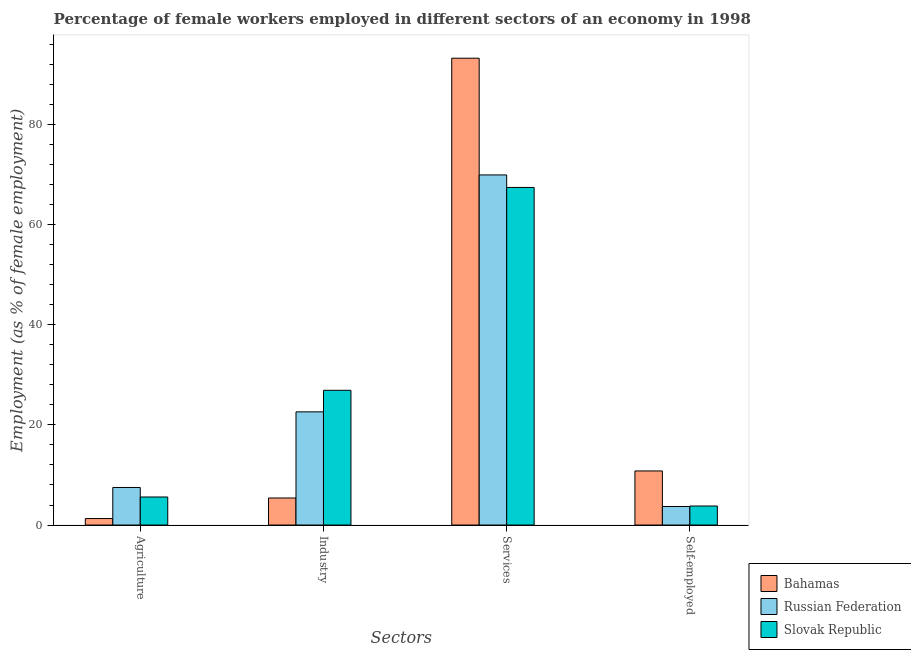How many groups of bars are there?
Your response must be concise. 4. Are the number of bars per tick equal to the number of legend labels?
Provide a short and direct response. Yes. How many bars are there on the 2nd tick from the left?
Offer a terse response. 3. What is the label of the 3rd group of bars from the left?
Give a very brief answer. Services. What is the percentage of self employed female workers in Bahamas?
Your answer should be very brief. 10.8. Across all countries, what is the maximum percentage of female workers in industry?
Offer a terse response. 26.9. Across all countries, what is the minimum percentage of female workers in industry?
Give a very brief answer. 5.4. In which country was the percentage of female workers in services maximum?
Ensure brevity in your answer.  Bahamas. In which country was the percentage of self employed female workers minimum?
Your response must be concise. Russian Federation. What is the total percentage of female workers in services in the graph?
Offer a very short reply. 230.5. What is the difference between the percentage of female workers in industry in Russian Federation and that in Bahamas?
Your answer should be very brief. 17.2. What is the difference between the percentage of female workers in industry in Bahamas and the percentage of female workers in agriculture in Slovak Republic?
Keep it short and to the point. -0.2. What is the average percentage of self employed female workers per country?
Offer a very short reply. 6.1. What is the difference between the percentage of female workers in agriculture and percentage of female workers in services in Slovak Republic?
Keep it short and to the point. -61.8. In how many countries, is the percentage of female workers in services greater than 40 %?
Your response must be concise. 3. What is the ratio of the percentage of female workers in industry in Slovak Republic to that in Russian Federation?
Give a very brief answer. 1.19. What is the difference between the highest and the second highest percentage of female workers in agriculture?
Provide a succinct answer. 1.9. What is the difference between the highest and the lowest percentage of female workers in services?
Offer a very short reply. 25.8. In how many countries, is the percentage of self employed female workers greater than the average percentage of self employed female workers taken over all countries?
Your answer should be compact. 1. Is the sum of the percentage of female workers in services in Bahamas and Russian Federation greater than the maximum percentage of female workers in industry across all countries?
Keep it short and to the point. Yes. Is it the case that in every country, the sum of the percentage of self employed female workers and percentage of female workers in services is greater than the sum of percentage of female workers in agriculture and percentage of female workers in industry?
Ensure brevity in your answer.  Yes. What does the 1st bar from the left in Agriculture represents?
Your answer should be very brief. Bahamas. What does the 3rd bar from the right in Services represents?
Provide a succinct answer. Bahamas. Is it the case that in every country, the sum of the percentage of female workers in agriculture and percentage of female workers in industry is greater than the percentage of female workers in services?
Your answer should be very brief. No. How many bars are there?
Offer a terse response. 12. How many countries are there in the graph?
Offer a terse response. 3. Does the graph contain any zero values?
Give a very brief answer. No. Does the graph contain grids?
Offer a very short reply. No. Where does the legend appear in the graph?
Your answer should be compact. Bottom right. How many legend labels are there?
Ensure brevity in your answer.  3. What is the title of the graph?
Your answer should be compact. Percentage of female workers employed in different sectors of an economy in 1998. What is the label or title of the X-axis?
Your answer should be compact. Sectors. What is the label or title of the Y-axis?
Ensure brevity in your answer.  Employment (as % of female employment). What is the Employment (as % of female employment) of Bahamas in Agriculture?
Provide a short and direct response. 1.3. What is the Employment (as % of female employment) in Russian Federation in Agriculture?
Provide a succinct answer. 7.5. What is the Employment (as % of female employment) of Slovak Republic in Agriculture?
Your answer should be compact. 5.6. What is the Employment (as % of female employment) of Bahamas in Industry?
Keep it short and to the point. 5.4. What is the Employment (as % of female employment) in Russian Federation in Industry?
Keep it short and to the point. 22.6. What is the Employment (as % of female employment) of Slovak Republic in Industry?
Your answer should be compact. 26.9. What is the Employment (as % of female employment) in Bahamas in Services?
Make the answer very short. 93.2. What is the Employment (as % of female employment) in Russian Federation in Services?
Your answer should be very brief. 69.9. What is the Employment (as % of female employment) of Slovak Republic in Services?
Make the answer very short. 67.4. What is the Employment (as % of female employment) in Bahamas in Self-employed?
Your response must be concise. 10.8. What is the Employment (as % of female employment) of Russian Federation in Self-employed?
Keep it short and to the point. 3.7. What is the Employment (as % of female employment) of Slovak Republic in Self-employed?
Provide a short and direct response. 3.8. Across all Sectors, what is the maximum Employment (as % of female employment) of Bahamas?
Keep it short and to the point. 93.2. Across all Sectors, what is the maximum Employment (as % of female employment) in Russian Federation?
Offer a very short reply. 69.9. Across all Sectors, what is the maximum Employment (as % of female employment) of Slovak Republic?
Provide a short and direct response. 67.4. Across all Sectors, what is the minimum Employment (as % of female employment) of Bahamas?
Your answer should be very brief. 1.3. Across all Sectors, what is the minimum Employment (as % of female employment) in Russian Federation?
Provide a succinct answer. 3.7. Across all Sectors, what is the minimum Employment (as % of female employment) in Slovak Republic?
Your response must be concise. 3.8. What is the total Employment (as % of female employment) of Bahamas in the graph?
Make the answer very short. 110.7. What is the total Employment (as % of female employment) of Russian Federation in the graph?
Your answer should be very brief. 103.7. What is the total Employment (as % of female employment) of Slovak Republic in the graph?
Provide a succinct answer. 103.7. What is the difference between the Employment (as % of female employment) in Bahamas in Agriculture and that in Industry?
Your answer should be compact. -4.1. What is the difference between the Employment (as % of female employment) of Russian Federation in Agriculture and that in Industry?
Offer a very short reply. -15.1. What is the difference between the Employment (as % of female employment) of Slovak Republic in Agriculture and that in Industry?
Ensure brevity in your answer.  -21.3. What is the difference between the Employment (as % of female employment) of Bahamas in Agriculture and that in Services?
Your response must be concise. -91.9. What is the difference between the Employment (as % of female employment) of Russian Federation in Agriculture and that in Services?
Give a very brief answer. -62.4. What is the difference between the Employment (as % of female employment) of Slovak Republic in Agriculture and that in Services?
Your response must be concise. -61.8. What is the difference between the Employment (as % of female employment) in Russian Federation in Agriculture and that in Self-employed?
Your answer should be very brief. 3.8. What is the difference between the Employment (as % of female employment) in Bahamas in Industry and that in Services?
Ensure brevity in your answer.  -87.8. What is the difference between the Employment (as % of female employment) in Russian Federation in Industry and that in Services?
Your answer should be compact. -47.3. What is the difference between the Employment (as % of female employment) in Slovak Republic in Industry and that in Services?
Provide a short and direct response. -40.5. What is the difference between the Employment (as % of female employment) of Russian Federation in Industry and that in Self-employed?
Your response must be concise. 18.9. What is the difference between the Employment (as % of female employment) in Slovak Republic in Industry and that in Self-employed?
Provide a short and direct response. 23.1. What is the difference between the Employment (as % of female employment) in Bahamas in Services and that in Self-employed?
Give a very brief answer. 82.4. What is the difference between the Employment (as % of female employment) of Russian Federation in Services and that in Self-employed?
Your answer should be very brief. 66.2. What is the difference between the Employment (as % of female employment) in Slovak Republic in Services and that in Self-employed?
Ensure brevity in your answer.  63.6. What is the difference between the Employment (as % of female employment) of Bahamas in Agriculture and the Employment (as % of female employment) of Russian Federation in Industry?
Give a very brief answer. -21.3. What is the difference between the Employment (as % of female employment) of Bahamas in Agriculture and the Employment (as % of female employment) of Slovak Republic in Industry?
Your answer should be compact. -25.6. What is the difference between the Employment (as % of female employment) of Russian Federation in Agriculture and the Employment (as % of female employment) of Slovak Republic in Industry?
Your answer should be very brief. -19.4. What is the difference between the Employment (as % of female employment) in Bahamas in Agriculture and the Employment (as % of female employment) in Russian Federation in Services?
Give a very brief answer. -68.6. What is the difference between the Employment (as % of female employment) in Bahamas in Agriculture and the Employment (as % of female employment) in Slovak Republic in Services?
Offer a very short reply. -66.1. What is the difference between the Employment (as % of female employment) of Russian Federation in Agriculture and the Employment (as % of female employment) of Slovak Republic in Services?
Your answer should be compact. -59.9. What is the difference between the Employment (as % of female employment) in Bahamas in Agriculture and the Employment (as % of female employment) in Russian Federation in Self-employed?
Make the answer very short. -2.4. What is the difference between the Employment (as % of female employment) in Bahamas in Agriculture and the Employment (as % of female employment) in Slovak Republic in Self-employed?
Offer a very short reply. -2.5. What is the difference between the Employment (as % of female employment) of Bahamas in Industry and the Employment (as % of female employment) of Russian Federation in Services?
Your answer should be very brief. -64.5. What is the difference between the Employment (as % of female employment) of Bahamas in Industry and the Employment (as % of female employment) of Slovak Republic in Services?
Ensure brevity in your answer.  -62. What is the difference between the Employment (as % of female employment) of Russian Federation in Industry and the Employment (as % of female employment) of Slovak Republic in Services?
Give a very brief answer. -44.8. What is the difference between the Employment (as % of female employment) in Bahamas in Industry and the Employment (as % of female employment) in Russian Federation in Self-employed?
Your response must be concise. 1.7. What is the difference between the Employment (as % of female employment) in Russian Federation in Industry and the Employment (as % of female employment) in Slovak Republic in Self-employed?
Offer a terse response. 18.8. What is the difference between the Employment (as % of female employment) in Bahamas in Services and the Employment (as % of female employment) in Russian Federation in Self-employed?
Your answer should be compact. 89.5. What is the difference between the Employment (as % of female employment) in Bahamas in Services and the Employment (as % of female employment) in Slovak Republic in Self-employed?
Your answer should be very brief. 89.4. What is the difference between the Employment (as % of female employment) in Russian Federation in Services and the Employment (as % of female employment) in Slovak Republic in Self-employed?
Your answer should be very brief. 66.1. What is the average Employment (as % of female employment) in Bahamas per Sectors?
Keep it short and to the point. 27.68. What is the average Employment (as % of female employment) of Russian Federation per Sectors?
Your response must be concise. 25.93. What is the average Employment (as % of female employment) in Slovak Republic per Sectors?
Offer a terse response. 25.93. What is the difference between the Employment (as % of female employment) in Bahamas and Employment (as % of female employment) in Slovak Republic in Agriculture?
Offer a terse response. -4.3. What is the difference between the Employment (as % of female employment) of Russian Federation and Employment (as % of female employment) of Slovak Republic in Agriculture?
Give a very brief answer. 1.9. What is the difference between the Employment (as % of female employment) of Bahamas and Employment (as % of female employment) of Russian Federation in Industry?
Give a very brief answer. -17.2. What is the difference between the Employment (as % of female employment) of Bahamas and Employment (as % of female employment) of Slovak Republic in Industry?
Your answer should be compact. -21.5. What is the difference between the Employment (as % of female employment) of Russian Federation and Employment (as % of female employment) of Slovak Republic in Industry?
Ensure brevity in your answer.  -4.3. What is the difference between the Employment (as % of female employment) of Bahamas and Employment (as % of female employment) of Russian Federation in Services?
Make the answer very short. 23.3. What is the difference between the Employment (as % of female employment) in Bahamas and Employment (as % of female employment) in Slovak Republic in Services?
Ensure brevity in your answer.  25.8. What is the difference between the Employment (as % of female employment) of Russian Federation and Employment (as % of female employment) of Slovak Republic in Services?
Your response must be concise. 2.5. What is the difference between the Employment (as % of female employment) of Bahamas and Employment (as % of female employment) of Russian Federation in Self-employed?
Give a very brief answer. 7.1. What is the difference between the Employment (as % of female employment) in Bahamas and Employment (as % of female employment) in Slovak Republic in Self-employed?
Offer a very short reply. 7. What is the difference between the Employment (as % of female employment) in Russian Federation and Employment (as % of female employment) in Slovak Republic in Self-employed?
Make the answer very short. -0.1. What is the ratio of the Employment (as % of female employment) in Bahamas in Agriculture to that in Industry?
Your answer should be very brief. 0.24. What is the ratio of the Employment (as % of female employment) in Russian Federation in Agriculture to that in Industry?
Ensure brevity in your answer.  0.33. What is the ratio of the Employment (as % of female employment) of Slovak Republic in Agriculture to that in Industry?
Offer a very short reply. 0.21. What is the ratio of the Employment (as % of female employment) of Bahamas in Agriculture to that in Services?
Give a very brief answer. 0.01. What is the ratio of the Employment (as % of female employment) of Russian Federation in Agriculture to that in Services?
Your answer should be very brief. 0.11. What is the ratio of the Employment (as % of female employment) of Slovak Republic in Agriculture to that in Services?
Your answer should be very brief. 0.08. What is the ratio of the Employment (as % of female employment) in Bahamas in Agriculture to that in Self-employed?
Offer a very short reply. 0.12. What is the ratio of the Employment (as % of female employment) in Russian Federation in Agriculture to that in Self-employed?
Offer a very short reply. 2.03. What is the ratio of the Employment (as % of female employment) in Slovak Republic in Agriculture to that in Self-employed?
Ensure brevity in your answer.  1.47. What is the ratio of the Employment (as % of female employment) in Bahamas in Industry to that in Services?
Your response must be concise. 0.06. What is the ratio of the Employment (as % of female employment) of Russian Federation in Industry to that in Services?
Your answer should be very brief. 0.32. What is the ratio of the Employment (as % of female employment) of Slovak Republic in Industry to that in Services?
Offer a terse response. 0.4. What is the ratio of the Employment (as % of female employment) in Russian Federation in Industry to that in Self-employed?
Ensure brevity in your answer.  6.11. What is the ratio of the Employment (as % of female employment) in Slovak Republic in Industry to that in Self-employed?
Make the answer very short. 7.08. What is the ratio of the Employment (as % of female employment) of Bahamas in Services to that in Self-employed?
Your answer should be very brief. 8.63. What is the ratio of the Employment (as % of female employment) of Russian Federation in Services to that in Self-employed?
Provide a succinct answer. 18.89. What is the ratio of the Employment (as % of female employment) of Slovak Republic in Services to that in Self-employed?
Your answer should be very brief. 17.74. What is the difference between the highest and the second highest Employment (as % of female employment) of Bahamas?
Keep it short and to the point. 82.4. What is the difference between the highest and the second highest Employment (as % of female employment) in Russian Federation?
Ensure brevity in your answer.  47.3. What is the difference between the highest and the second highest Employment (as % of female employment) of Slovak Republic?
Ensure brevity in your answer.  40.5. What is the difference between the highest and the lowest Employment (as % of female employment) in Bahamas?
Ensure brevity in your answer.  91.9. What is the difference between the highest and the lowest Employment (as % of female employment) in Russian Federation?
Your answer should be very brief. 66.2. What is the difference between the highest and the lowest Employment (as % of female employment) in Slovak Republic?
Your response must be concise. 63.6. 